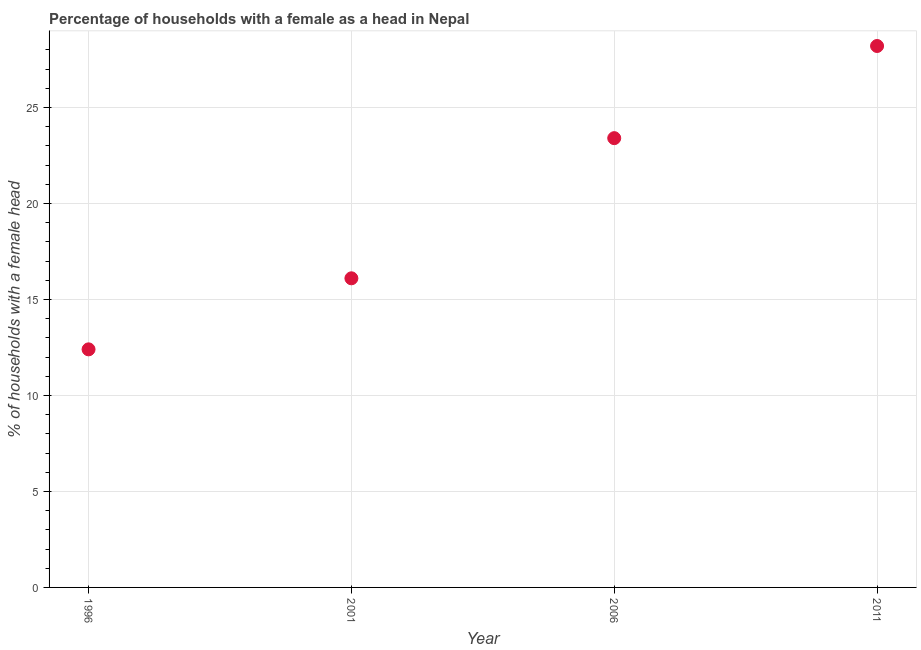Across all years, what is the maximum number of female supervised households?
Offer a terse response. 28.2. Across all years, what is the minimum number of female supervised households?
Your answer should be very brief. 12.4. In which year was the number of female supervised households minimum?
Ensure brevity in your answer.  1996. What is the sum of the number of female supervised households?
Your response must be concise. 80.1. What is the difference between the number of female supervised households in 2001 and 2011?
Offer a terse response. -12.1. What is the average number of female supervised households per year?
Keep it short and to the point. 20.02. What is the median number of female supervised households?
Your response must be concise. 19.75. What is the ratio of the number of female supervised households in 2001 to that in 2006?
Your response must be concise. 0.69. Is the number of female supervised households in 1996 less than that in 2006?
Your answer should be compact. Yes. Is the difference between the number of female supervised households in 2006 and 2011 greater than the difference between any two years?
Give a very brief answer. No. What is the difference between the highest and the second highest number of female supervised households?
Give a very brief answer. 4.8. Is the sum of the number of female supervised households in 1996 and 2001 greater than the maximum number of female supervised households across all years?
Offer a very short reply. Yes. What is the difference between the highest and the lowest number of female supervised households?
Ensure brevity in your answer.  15.8. How many dotlines are there?
Make the answer very short. 1. Are the values on the major ticks of Y-axis written in scientific E-notation?
Ensure brevity in your answer.  No. What is the title of the graph?
Your answer should be very brief. Percentage of households with a female as a head in Nepal. What is the label or title of the X-axis?
Give a very brief answer. Year. What is the label or title of the Y-axis?
Your answer should be compact. % of households with a female head. What is the % of households with a female head in 2001?
Your response must be concise. 16.1. What is the % of households with a female head in 2006?
Ensure brevity in your answer.  23.4. What is the % of households with a female head in 2011?
Ensure brevity in your answer.  28.2. What is the difference between the % of households with a female head in 1996 and 2006?
Your answer should be very brief. -11. What is the difference between the % of households with a female head in 1996 and 2011?
Keep it short and to the point. -15.8. What is the difference between the % of households with a female head in 2001 and 2011?
Your response must be concise. -12.1. What is the ratio of the % of households with a female head in 1996 to that in 2001?
Offer a very short reply. 0.77. What is the ratio of the % of households with a female head in 1996 to that in 2006?
Your answer should be very brief. 0.53. What is the ratio of the % of households with a female head in 1996 to that in 2011?
Your response must be concise. 0.44. What is the ratio of the % of households with a female head in 2001 to that in 2006?
Give a very brief answer. 0.69. What is the ratio of the % of households with a female head in 2001 to that in 2011?
Your answer should be very brief. 0.57. What is the ratio of the % of households with a female head in 2006 to that in 2011?
Make the answer very short. 0.83. 